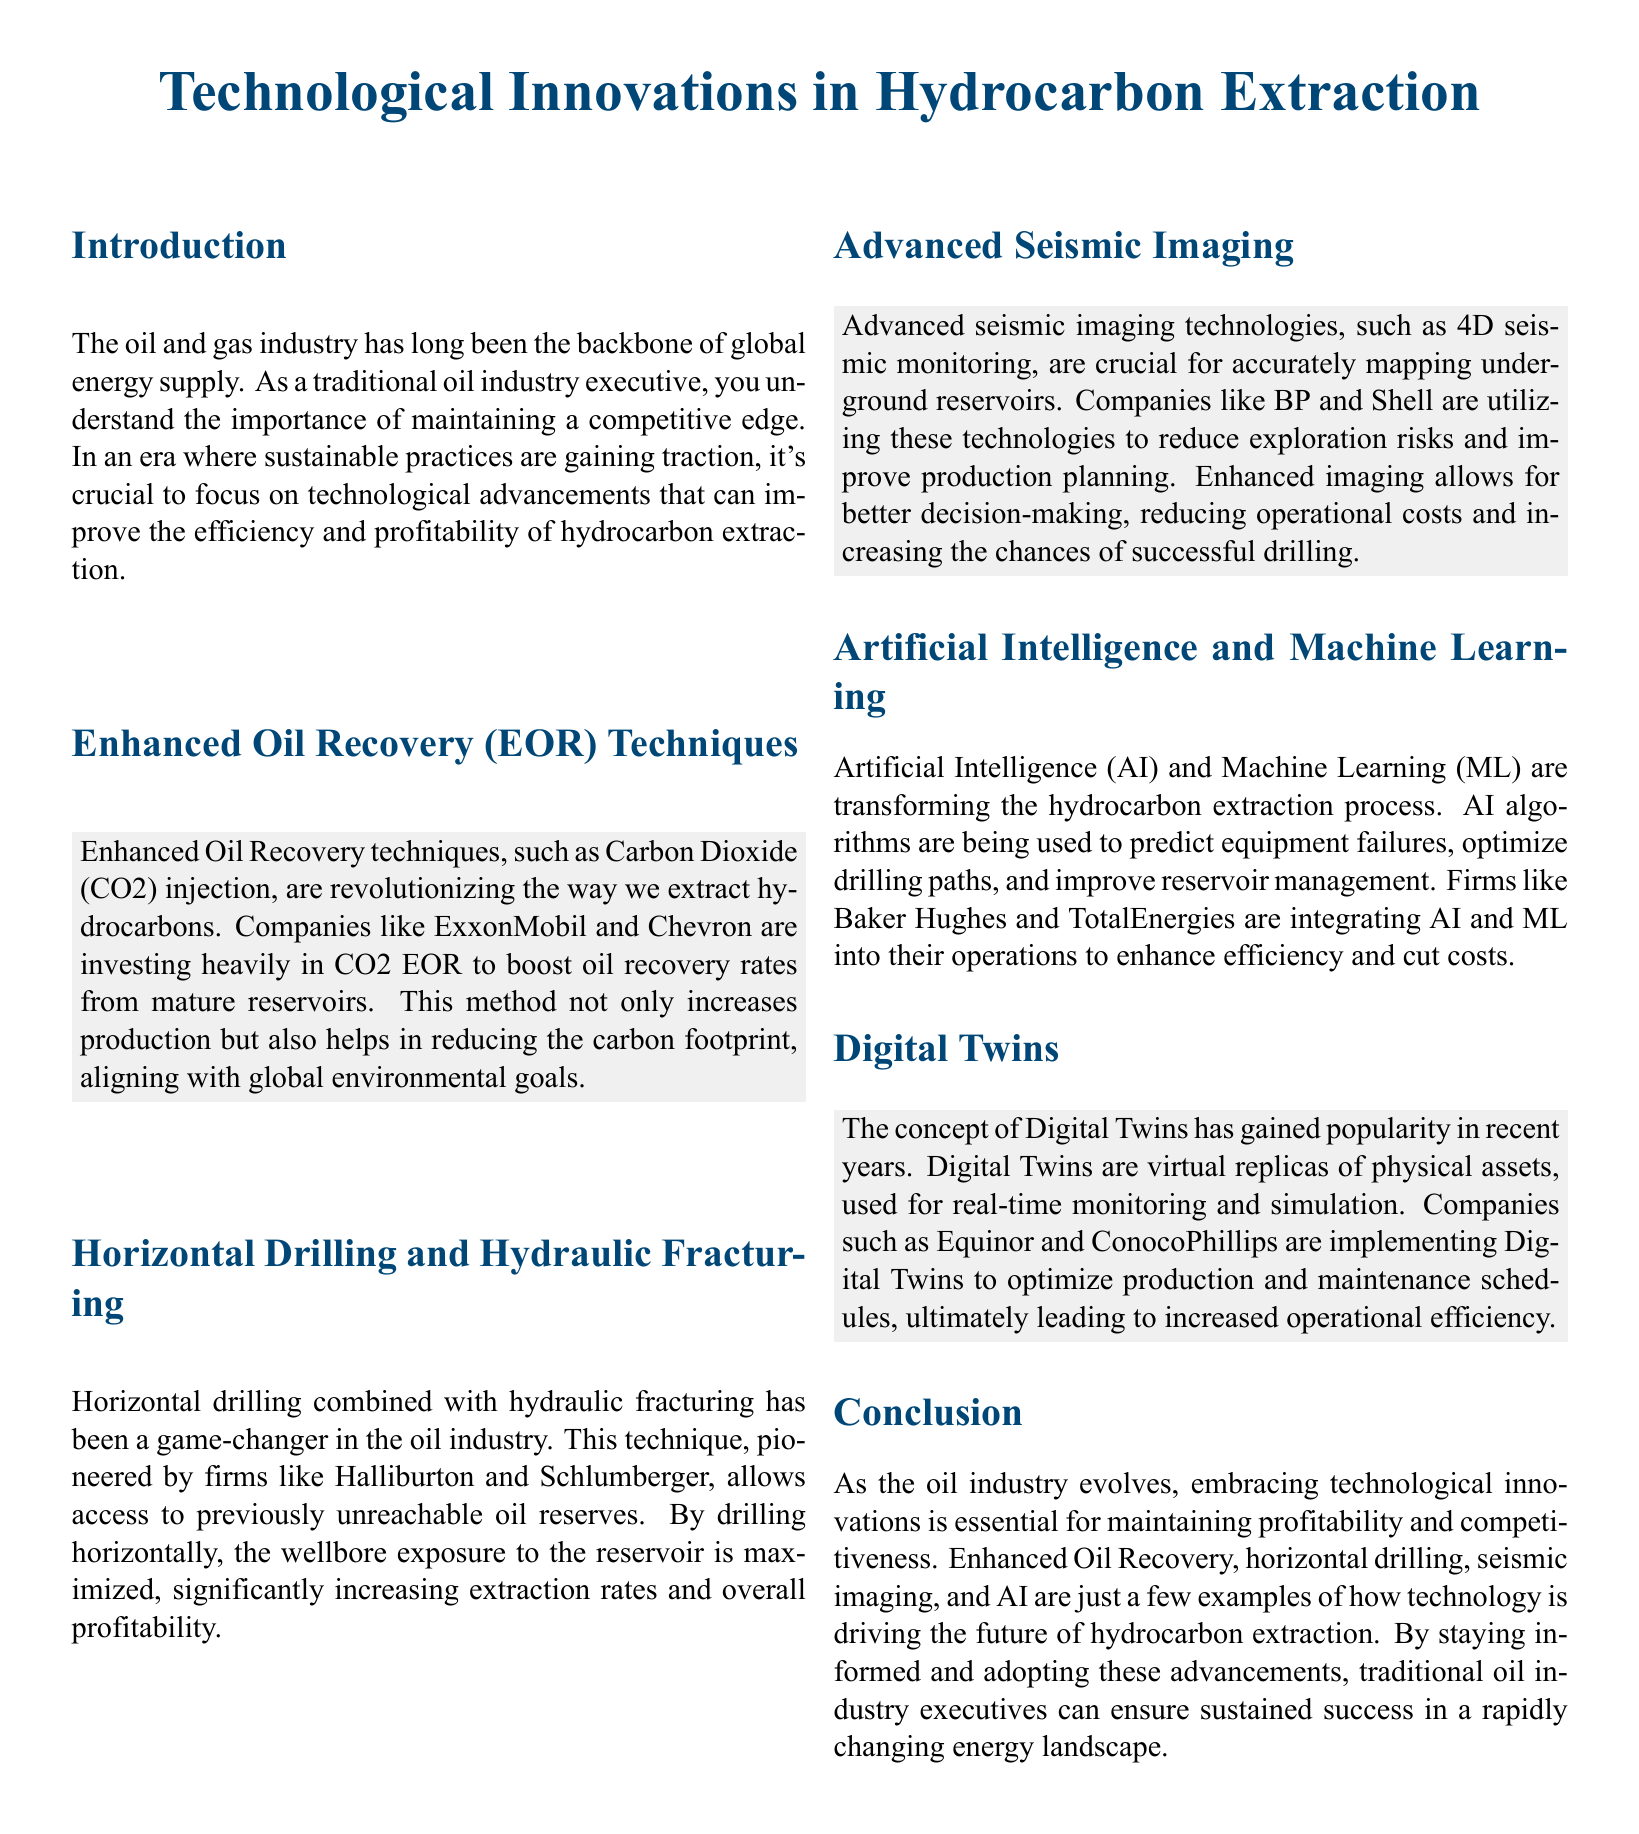What are Enhanced Oil Recovery techniques? Enhanced Oil Recovery techniques involve methods, such as Carbon Dioxide injection, to boost oil recovery rates from mature reservoirs.
Answer: Carbon Dioxide injection Which companies are investing in CO2 EOR? ExxonMobil and Chevron are investing heavily in CO2 Enhanced Oil Recovery techniques.
Answer: ExxonMobil and Chevron What drilling method maximizes exposure to reservoirs? The method that maximizes exposure to reservoirs is horizontal drilling.
Answer: Horizontal drilling What technology is used for accurately mapping underground reservoirs? Advanced seismic imaging technologies, such as 4D seismic monitoring, are used for mapping.
Answer: 4D seismic monitoring Which companies utilize advanced seismic imaging? BP and Shell are utilizing advanced seismic imaging technologies.
Answer: BP and Shell What role does AI play in hydrocarbon extraction? AI is used to predict equipment failures and optimize drilling paths.
Answer: Predict equipment failures and optimize drilling paths What is a Digital Twin? A Digital Twin is a virtual replica of physical assets for real-time monitoring.
Answer: Virtual replica of physical assets Which companies are implementing Digital Twins? Equinor and ConocoPhillips are implementing Digital Twins in their operations.
Answer: Equinor and ConocoPhillips What is the overall goal of adopting technological innovations in the oil industry? The overall goal is to maintain profitability and competitiveness in the energy sector.
Answer: Maintain profitability and competitiveness 